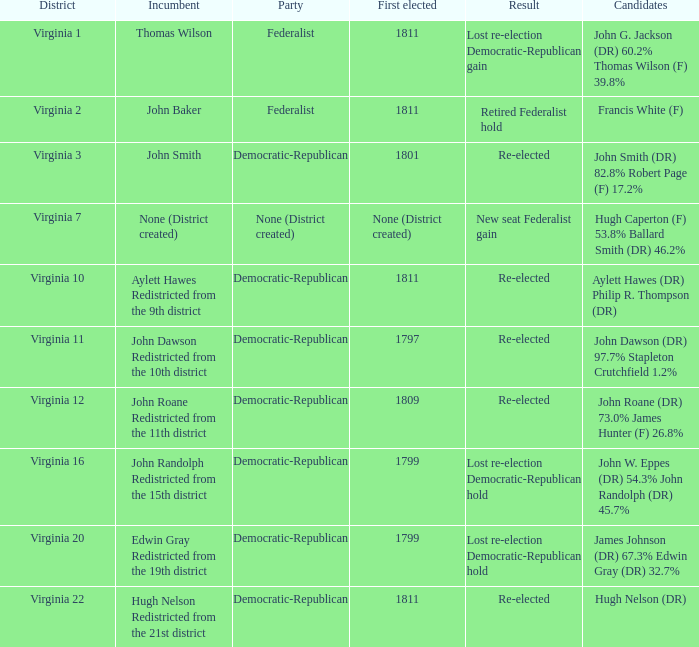Name the party for virginia 12 Democratic-Republican. 